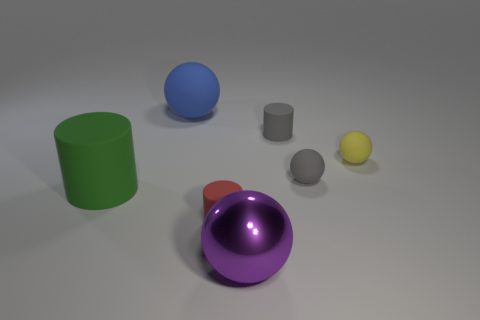Subtract all small gray matte cylinders. How many cylinders are left? 2 Add 2 small brown rubber objects. How many objects exist? 9 Subtract all gray spheres. How many spheres are left? 3 Subtract 1 cylinders. How many cylinders are left? 2 Subtract all balls. How many objects are left? 3 Subtract all brown cylinders. Subtract all yellow spheres. How many cylinders are left? 3 Add 7 large rubber things. How many large rubber things exist? 9 Subtract 0 cyan balls. How many objects are left? 7 Subtract all small matte cylinders. Subtract all purple metallic spheres. How many objects are left? 4 Add 6 red matte cylinders. How many red matte cylinders are left? 7 